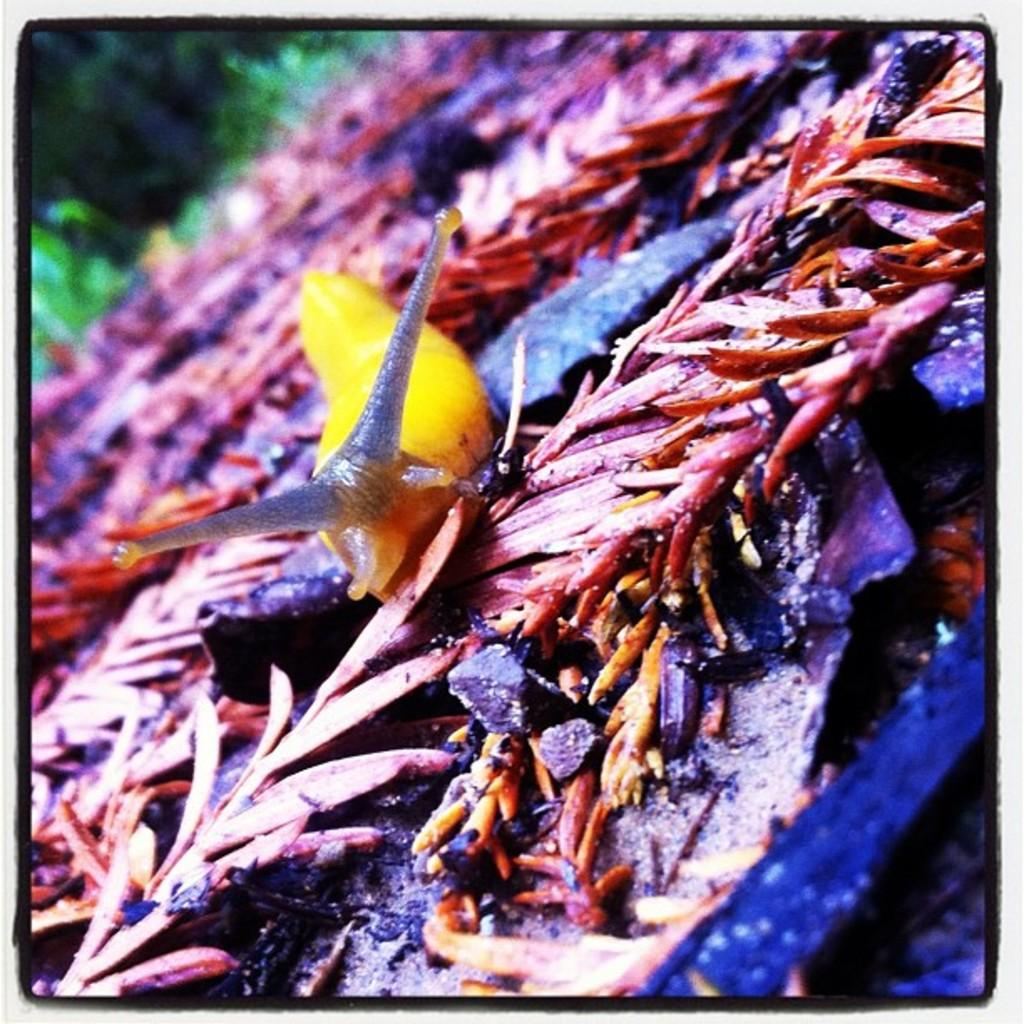What type of animal is in the image? There is a snail in the image. Where is the snail located? The snail is on the plants. What type of plot is the snail involved in within the image? There is no plot or storyline depicted in the image; it simply shows a snail on the plants. 